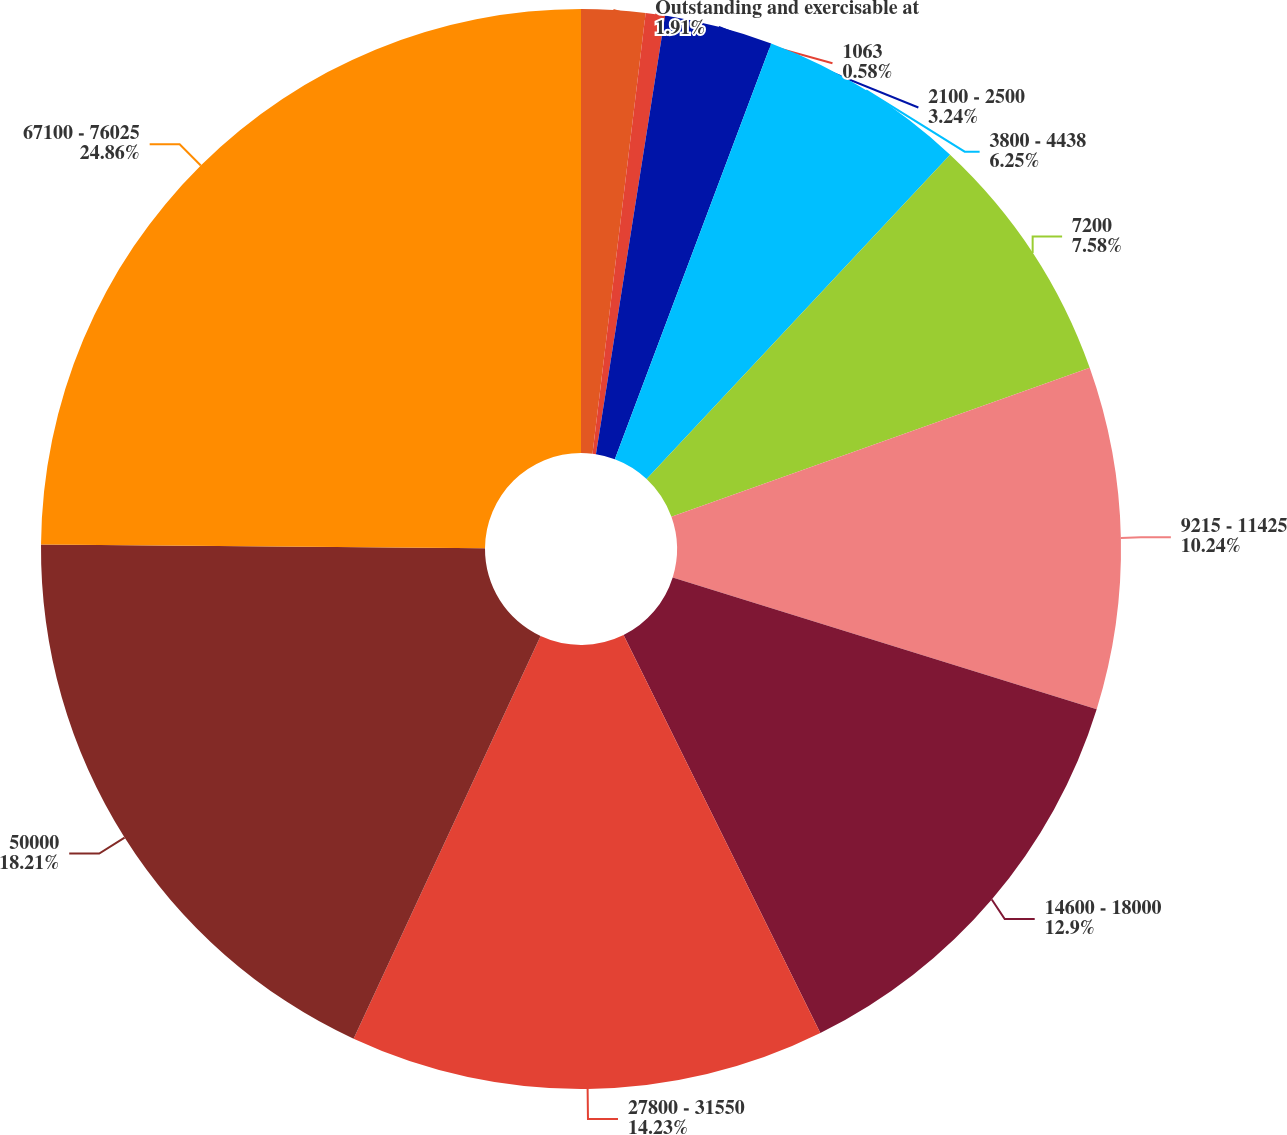Convert chart to OTSL. <chart><loc_0><loc_0><loc_500><loc_500><pie_chart><fcel>Outstanding and exercisable at<fcel>1063<fcel>2100 - 2500<fcel>3800 - 4438<fcel>7200<fcel>9215 - 11425<fcel>14600 - 18000<fcel>27800 - 31550<fcel>50000<fcel>67100 - 76025<nl><fcel>1.91%<fcel>0.58%<fcel>3.24%<fcel>6.25%<fcel>7.58%<fcel>10.24%<fcel>12.9%<fcel>14.23%<fcel>18.22%<fcel>24.87%<nl></chart> 